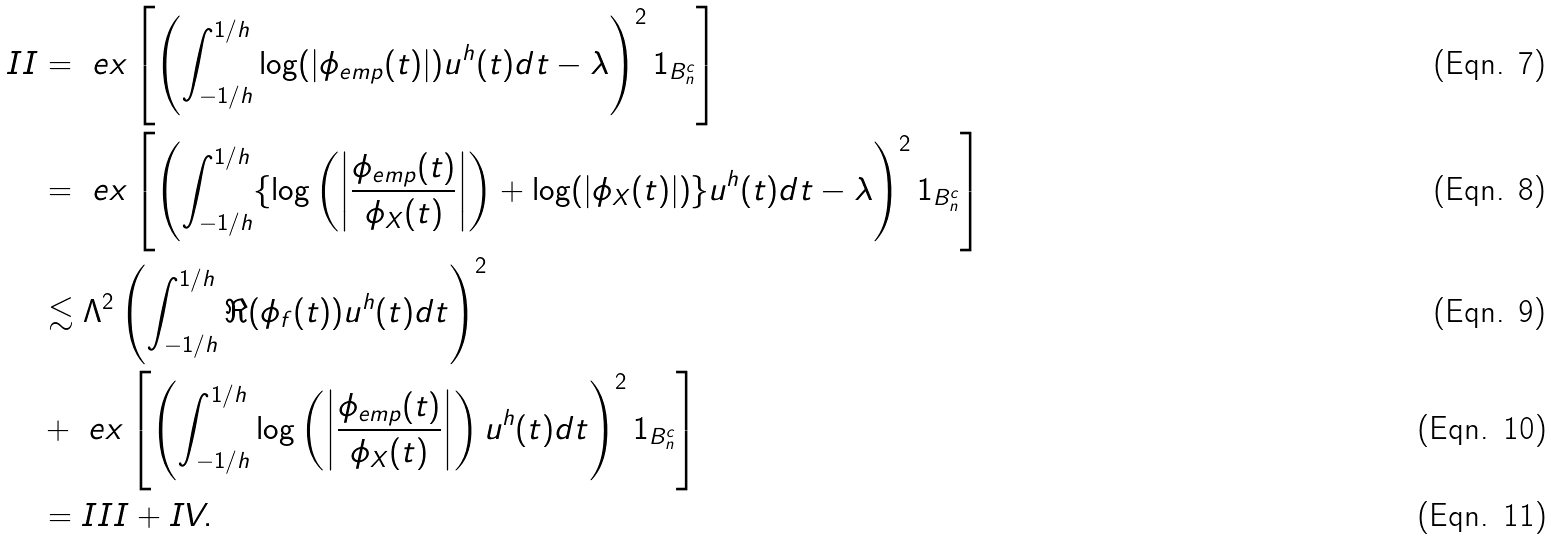<formula> <loc_0><loc_0><loc_500><loc_500>I I & = \ e x \left [ \left ( \int _ { - 1 / h } ^ { 1 / h } \log ( | \phi _ { e m p } ( t ) | ) u ^ { h } ( t ) d t - \lambda \right ) ^ { 2 } 1 _ { B _ { n } ^ { c } } \right ] \\ & = \ e x \left [ \left ( \int _ { - 1 / h } ^ { 1 / h } \{ \log \left ( \left | \frac { \phi _ { e m p } ( t ) } { \phi _ { X } ( t ) } \right | \right ) + \log ( | \phi _ { X } ( t ) | ) \} u ^ { h } ( t ) d t - \lambda \right ) ^ { 2 } 1 _ { B _ { n } ^ { c } } \right ] \\ & \lesssim \Lambda ^ { 2 } \left ( \int _ { - 1 / h } ^ { 1 / h } \Re ( \phi _ { f } ( t ) ) u ^ { h } ( t ) d t \right ) ^ { 2 } \\ & + \ e x \left [ \left ( \int _ { - 1 / h } ^ { 1 / h } \log \left ( \left | \frac { \phi _ { e m p } ( t ) } { \phi _ { X } ( t ) } \right | \right ) u ^ { h } ( t ) d t \right ) ^ { 2 } 1 _ { B _ { n } ^ { c } } \right ] \\ & = I I I + I V .</formula> 